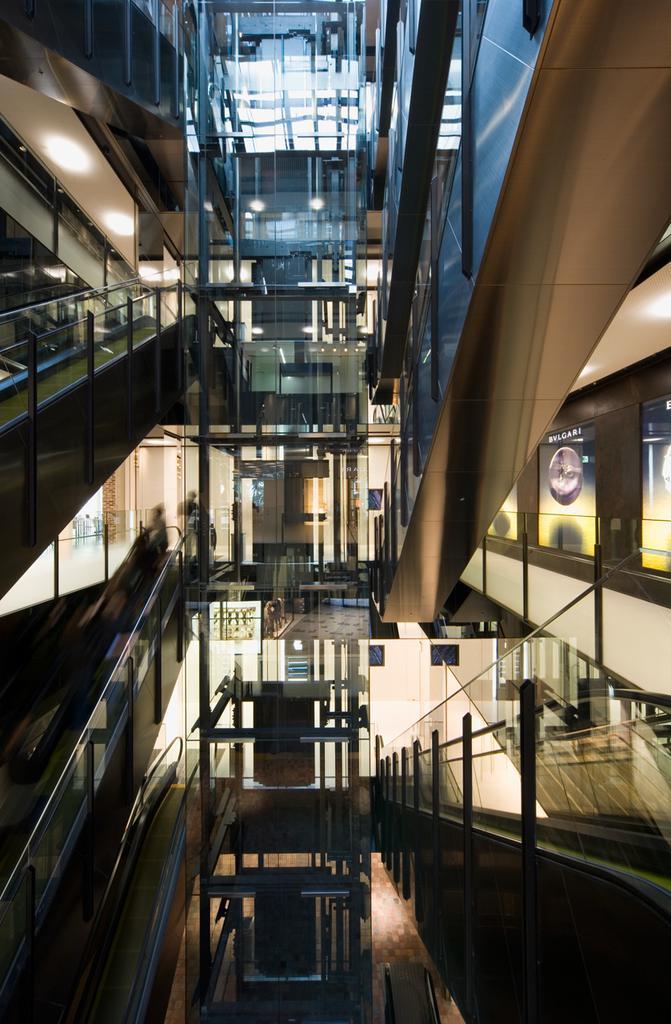Can you describe this image briefly? The picture is taken inside a building. In this picture there are staircases. 